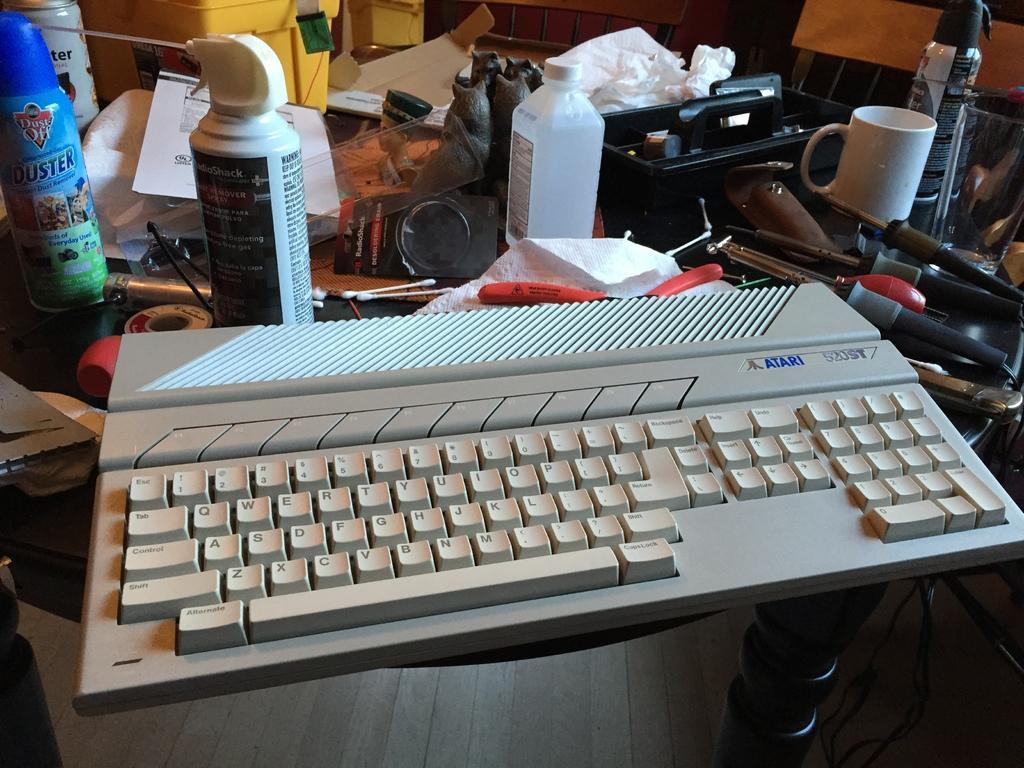How would you summarize this image in a sentence or two? In this image in the center there is one keyboard and on the background there are some bottles, one cup, and some instruments are there on the table and one box, paper and one tissue paper is there. 